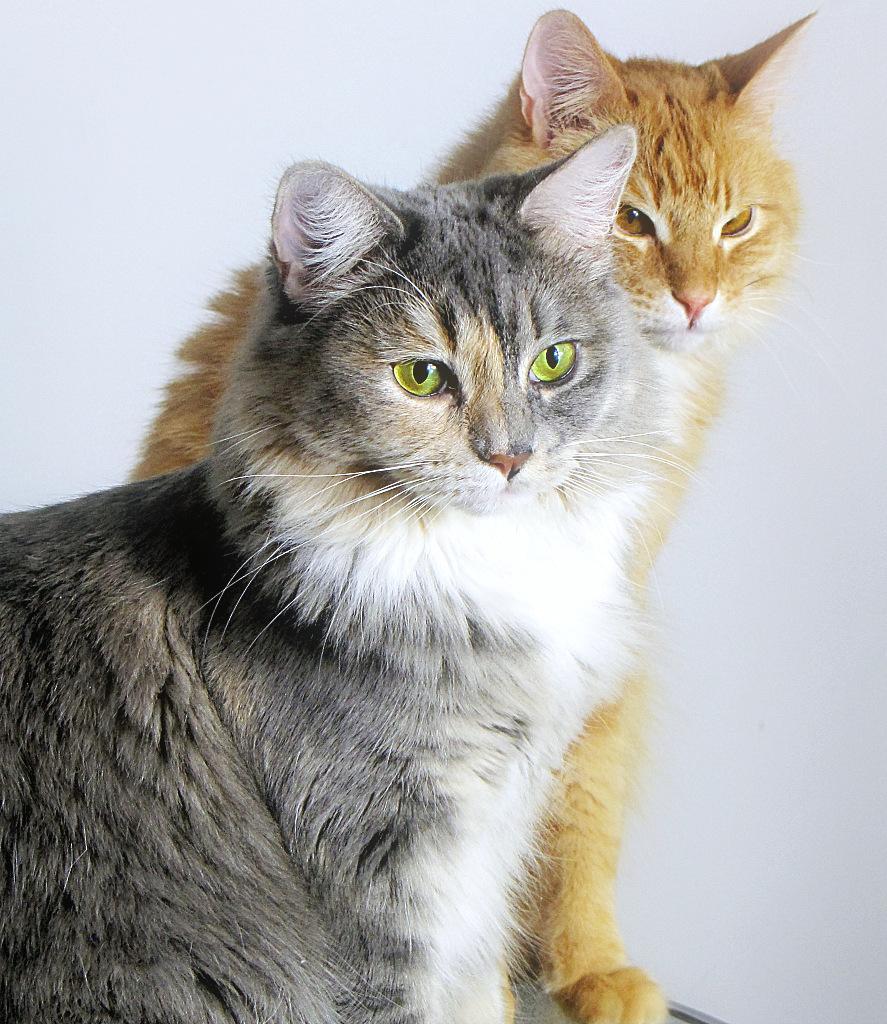Please provide a concise description of this image. In this image I can see two cats. They are in brown,white and grey color. Background is in white color. 